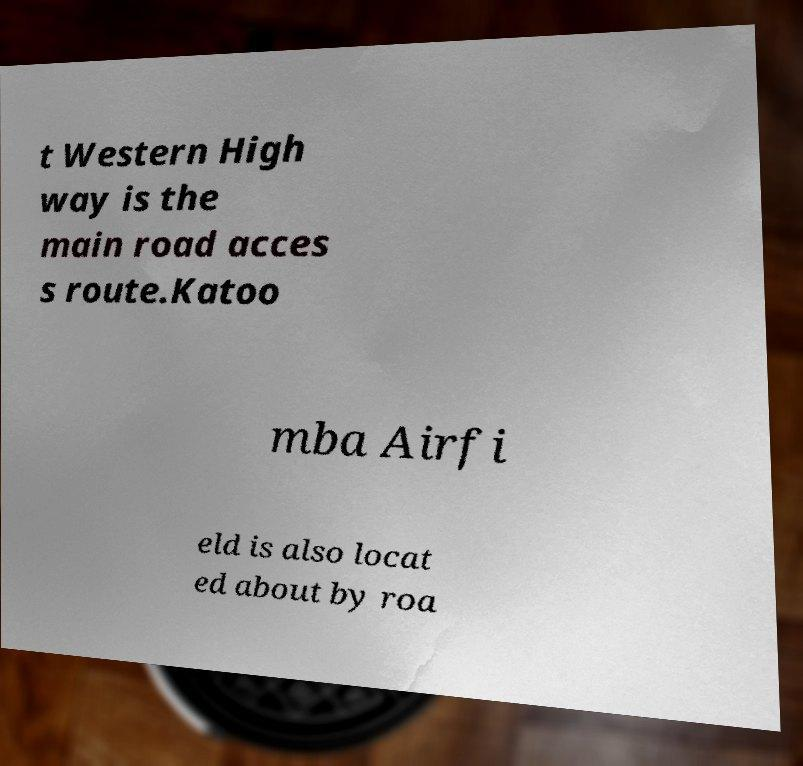Could you assist in decoding the text presented in this image and type it out clearly? t Western High way is the main road acces s route.Katoo mba Airfi eld is also locat ed about by roa 